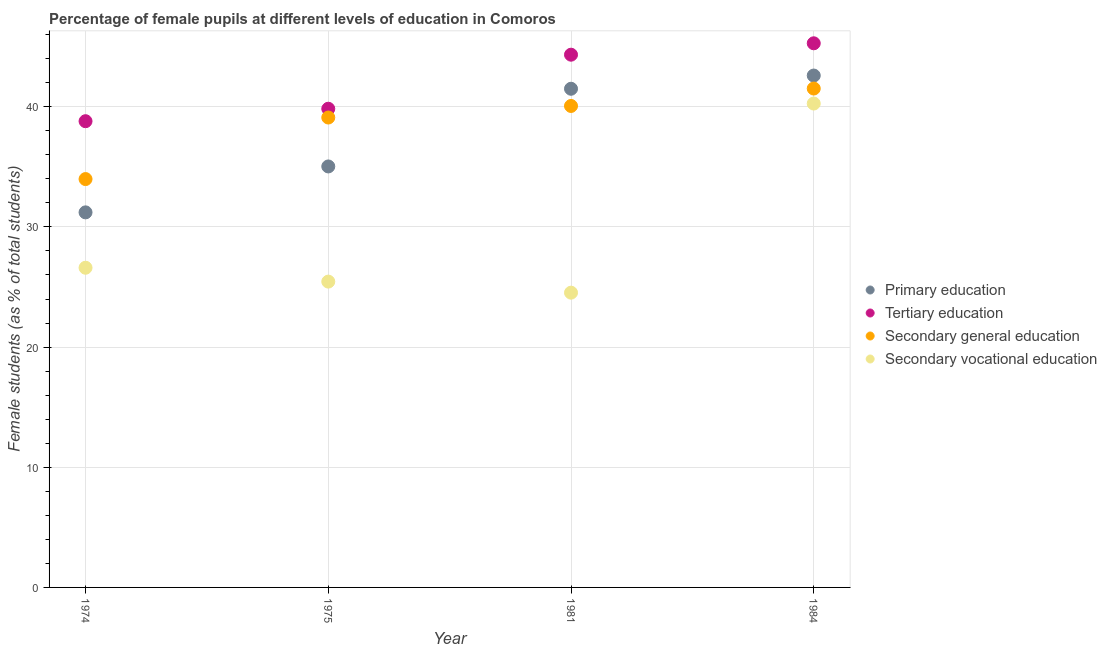What is the percentage of female students in secondary vocational education in 1981?
Your response must be concise. 24.53. Across all years, what is the maximum percentage of female students in secondary education?
Your response must be concise. 41.51. Across all years, what is the minimum percentage of female students in secondary vocational education?
Your answer should be compact. 24.53. In which year was the percentage of female students in tertiary education maximum?
Provide a succinct answer. 1984. In which year was the percentage of female students in secondary vocational education minimum?
Keep it short and to the point. 1981. What is the total percentage of female students in primary education in the graph?
Keep it short and to the point. 150.33. What is the difference between the percentage of female students in secondary education in 1974 and that in 1975?
Ensure brevity in your answer.  -5.12. What is the difference between the percentage of female students in secondary education in 1981 and the percentage of female students in secondary vocational education in 1974?
Provide a succinct answer. 13.46. What is the average percentage of female students in secondary vocational education per year?
Provide a short and direct response. 29.21. In the year 1975, what is the difference between the percentage of female students in primary education and percentage of female students in secondary vocational education?
Provide a short and direct response. 9.58. What is the ratio of the percentage of female students in secondary vocational education in 1975 to that in 1981?
Your response must be concise. 1.04. Is the percentage of female students in secondary vocational education in 1981 less than that in 1984?
Offer a terse response. Yes. Is the difference between the percentage of female students in tertiary education in 1981 and 1984 greater than the difference between the percentage of female students in primary education in 1981 and 1984?
Keep it short and to the point. Yes. What is the difference between the highest and the second highest percentage of female students in tertiary education?
Offer a very short reply. 0.95. What is the difference between the highest and the lowest percentage of female students in tertiary education?
Your response must be concise. 6.48. In how many years, is the percentage of female students in primary education greater than the average percentage of female students in primary education taken over all years?
Provide a succinct answer. 2. Does the percentage of female students in primary education monotonically increase over the years?
Provide a short and direct response. Yes. Is the percentage of female students in primary education strictly greater than the percentage of female students in secondary vocational education over the years?
Provide a succinct answer. Yes. What is the difference between two consecutive major ticks on the Y-axis?
Your answer should be compact. 10. Does the graph contain grids?
Offer a terse response. Yes. How are the legend labels stacked?
Offer a terse response. Vertical. What is the title of the graph?
Offer a very short reply. Percentage of female pupils at different levels of education in Comoros. What is the label or title of the Y-axis?
Provide a succinct answer. Female students (as % of total students). What is the Female students (as % of total students) in Primary education in 1974?
Your response must be concise. 31.21. What is the Female students (as % of total students) in Tertiary education in 1974?
Your answer should be compact. 38.8. What is the Female students (as % of total students) of Secondary general education in 1974?
Keep it short and to the point. 33.98. What is the Female students (as % of total students) in Secondary vocational education in 1974?
Keep it short and to the point. 26.6. What is the Female students (as % of total students) in Primary education in 1975?
Give a very brief answer. 35.03. What is the Female students (as % of total students) of Tertiary education in 1975?
Make the answer very short. 39.83. What is the Female students (as % of total students) of Secondary general education in 1975?
Your answer should be compact. 39.1. What is the Female students (as % of total students) in Secondary vocational education in 1975?
Your response must be concise. 25.45. What is the Female students (as % of total students) of Primary education in 1981?
Your response must be concise. 41.5. What is the Female students (as % of total students) in Tertiary education in 1981?
Your answer should be compact. 44.33. What is the Female students (as % of total students) in Secondary general education in 1981?
Ensure brevity in your answer.  40.06. What is the Female students (as % of total students) of Secondary vocational education in 1981?
Your answer should be compact. 24.53. What is the Female students (as % of total students) in Primary education in 1984?
Your answer should be compact. 42.6. What is the Female students (as % of total students) in Tertiary education in 1984?
Your answer should be very brief. 45.28. What is the Female students (as % of total students) in Secondary general education in 1984?
Keep it short and to the point. 41.51. What is the Female students (as % of total students) in Secondary vocational education in 1984?
Your answer should be compact. 40.27. Across all years, what is the maximum Female students (as % of total students) of Primary education?
Provide a succinct answer. 42.6. Across all years, what is the maximum Female students (as % of total students) of Tertiary education?
Your answer should be very brief. 45.28. Across all years, what is the maximum Female students (as % of total students) in Secondary general education?
Keep it short and to the point. 41.51. Across all years, what is the maximum Female students (as % of total students) of Secondary vocational education?
Offer a very short reply. 40.27. Across all years, what is the minimum Female students (as % of total students) of Primary education?
Provide a short and direct response. 31.21. Across all years, what is the minimum Female students (as % of total students) in Tertiary education?
Your answer should be compact. 38.8. Across all years, what is the minimum Female students (as % of total students) of Secondary general education?
Your response must be concise. 33.98. Across all years, what is the minimum Female students (as % of total students) in Secondary vocational education?
Give a very brief answer. 24.53. What is the total Female students (as % of total students) of Primary education in the graph?
Make the answer very short. 150.33. What is the total Female students (as % of total students) in Tertiary education in the graph?
Ensure brevity in your answer.  168.24. What is the total Female students (as % of total students) in Secondary general education in the graph?
Provide a succinct answer. 154.66. What is the total Female students (as % of total students) in Secondary vocational education in the graph?
Your response must be concise. 116.84. What is the difference between the Female students (as % of total students) of Primary education in 1974 and that in 1975?
Your answer should be compact. -3.82. What is the difference between the Female students (as % of total students) of Tertiary education in 1974 and that in 1975?
Offer a terse response. -1.04. What is the difference between the Female students (as % of total students) in Secondary general education in 1974 and that in 1975?
Your answer should be very brief. -5.12. What is the difference between the Female students (as % of total students) in Secondary vocational education in 1974 and that in 1975?
Offer a very short reply. 1.15. What is the difference between the Female students (as % of total students) in Primary education in 1974 and that in 1981?
Your answer should be very brief. -10.29. What is the difference between the Female students (as % of total students) in Tertiary education in 1974 and that in 1981?
Keep it short and to the point. -5.53. What is the difference between the Female students (as % of total students) of Secondary general education in 1974 and that in 1981?
Offer a very short reply. -6.08. What is the difference between the Female students (as % of total students) in Secondary vocational education in 1974 and that in 1981?
Your answer should be very brief. 2.07. What is the difference between the Female students (as % of total students) in Primary education in 1974 and that in 1984?
Give a very brief answer. -11.39. What is the difference between the Female students (as % of total students) in Tertiary education in 1974 and that in 1984?
Provide a short and direct response. -6.48. What is the difference between the Female students (as % of total students) of Secondary general education in 1974 and that in 1984?
Ensure brevity in your answer.  -7.53. What is the difference between the Female students (as % of total students) of Secondary vocational education in 1974 and that in 1984?
Provide a succinct answer. -13.66. What is the difference between the Female students (as % of total students) of Primary education in 1975 and that in 1981?
Keep it short and to the point. -6.46. What is the difference between the Female students (as % of total students) of Tertiary education in 1975 and that in 1981?
Provide a succinct answer. -4.5. What is the difference between the Female students (as % of total students) in Secondary general education in 1975 and that in 1981?
Your answer should be very brief. -0.96. What is the difference between the Female students (as % of total students) in Secondary vocational education in 1975 and that in 1981?
Your answer should be compact. 0.92. What is the difference between the Female students (as % of total students) of Primary education in 1975 and that in 1984?
Ensure brevity in your answer.  -7.56. What is the difference between the Female students (as % of total students) in Tertiary education in 1975 and that in 1984?
Your response must be concise. -5.45. What is the difference between the Female students (as % of total students) of Secondary general education in 1975 and that in 1984?
Make the answer very short. -2.41. What is the difference between the Female students (as % of total students) of Secondary vocational education in 1975 and that in 1984?
Offer a very short reply. -14.82. What is the difference between the Female students (as % of total students) in Primary education in 1981 and that in 1984?
Provide a succinct answer. -1.1. What is the difference between the Female students (as % of total students) in Tertiary education in 1981 and that in 1984?
Offer a very short reply. -0.95. What is the difference between the Female students (as % of total students) in Secondary general education in 1981 and that in 1984?
Your answer should be very brief. -1.45. What is the difference between the Female students (as % of total students) in Secondary vocational education in 1981 and that in 1984?
Give a very brief answer. -15.74. What is the difference between the Female students (as % of total students) of Primary education in 1974 and the Female students (as % of total students) of Tertiary education in 1975?
Your answer should be very brief. -8.62. What is the difference between the Female students (as % of total students) of Primary education in 1974 and the Female students (as % of total students) of Secondary general education in 1975?
Offer a terse response. -7.89. What is the difference between the Female students (as % of total students) of Primary education in 1974 and the Female students (as % of total students) of Secondary vocational education in 1975?
Your answer should be very brief. 5.76. What is the difference between the Female students (as % of total students) in Tertiary education in 1974 and the Female students (as % of total students) in Secondary general education in 1975?
Your answer should be very brief. -0.31. What is the difference between the Female students (as % of total students) of Tertiary education in 1974 and the Female students (as % of total students) of Secondary vocational education in 1975?
Your response must be concise. 13.35. What is the difference between the Female students (as % of total students) in Secondary general education in 1974 and the Female students (as % of total students) in Secondary vocational education in 1975?
Offer a very short reply. 8.53. What is the difference between the Female students (as % of total students) of Primary education in 1974 and the Female students (as % of total students) of Tertiary education in 1981?
Keep it short and to the point. -13.12. What is the difference between the Female students (as % of total students) in Primary education in 1974 and the Female students (as % of total students) in Secondary general education in 1981?
Provide a short and direct response. -8.85. What is the difference between the Female students (as % of total students) of Primary education in 1974 and the Female students (as % of total students) of Secondary vocational education in 1981?
Provide a short and direct response. 6.68. What is the difference between the Female students (as % of total students) of Tertiary education in 1974 and the Female students (as % of total students) of Secondary general education in 1981?
Offer a terse response. -1.27. What is the difference between the Female students (as % of total students) in Tertiary education in 1974 and the Female students (as % of total students) in Secondary vocational education in 1981?
Your answer should be compact. 14.27. What is the difference between the Female students (as % of total students) of Secondary general education in 1974 and the Female students (as % of total students) of Secondary vocational education in 1981?
Provide a short and direct response. 9.45. What is the difference between the Female students (as % of total students) of Primary education in 1974 and the Female students (as % of total students) of Tertiary education in 1984?
Give a very brief answer. -14.07. What is the difference between the Female students (as % of total students) of Primary education in 1974 and the Female students (as % of total students) of Secondary general education in 1984?
Give a very brief answer. -10.3. What is the difference between the Female students (as % of total students) in Primary education in 1974 and the Female students (as % of total students) in Secondary vocational education in 1984?
Offer a very short reply. -9.05. What is the difference between the Female students (as % of total students) of Tertiary education in 1974 and the Female students (as % of total students) of Secondary general education in 1984?
Offer a terse response. -2.72. What is the difference between the Female students (as % of total students) in Tertiary education in 1974 and the Female students (as % of total students) in Secondary vocational education in 1984?
Ensure brevity in your answer.  -1.47. What is the difference between the Female students (as % of total students) in Secondary general education in 1974 and the Female students (as % of total students) in Secondary vocational education in 1984?
Offer a very short reply. -6.28. What is the difference between the Female students (as % of total students) of Primary education in 1975 and the Female students (as % of total students) of Tertiary education in 1981?
Offer a very short reply. -9.3. What is the difference between the Female students (as % of total students) in Primary education in 1975 and the Female students (as % of total students) in Secondary general education in 1981?
Provide a succinct answer. -5.03. What is the difference between the Female students (as % of total students) in Primary education in 1975 and the Female students (as % of total students) in Secondary vocational education in 1981?
Offer a very short reply. 10.5. What is the difference between the Female students (as % of total students) in Tertiary education in 1975 and the Female students (as % of total students) in Secondary general education in 1981?
Make the answer very short. -0.23. What is the difference between the Female students (as % of total students) of Tertiary education in 1975 and the Female students (as % of total students) of Secondary vocational education in 1981?
Give a very brief answer. 15.31. What is the difference between the Female students (as % of total students) in Secondary general education in 1975 and the Female students (as % of total students) in Secondary vocational education in 1981?
Offer a very short reply. 14.57. What is the difference between the Female students (as % of total students) in Primary education in 1975 and the Female students (as % of total students) in Tertiary education in 1984?
Provide a short and direct response. -10.25. What is the difference between the Female students (as % of total students) of Primary education in 1975 and the Female students (as % of total students) of Secondary general education in 1984?
Your answer should be very brief. -6.48. What is the difference between the Female students (as % of total students) in Primary education in 1975 and the Female students (as % of total students) in Secondary vocational education in 1984?
Provide a short and direct response. -5.23. What is the difference between the Female students (as % of total students) of Tertiary education in 1975 and the Female students (as % of total students) of Secondary general education in 1984?
Offer a very short reply. -1.68. What is the difference between the Female students (as % of total students) in Tertiary education in 1975 and the Female students (as % of total students) in Secondary vocational education in 1984?
Keep it short and to the point. -0.43. What is the difference between the Female students (as % of total students) of Secondary general education in 1975 and the Female students (as % of total students) of Secondary vocational education in 1984?
Your answer should be very brief. -1.16. What is the difference between the Female students (as % of total students) in Primary education in 1981 and the Female students (as % of total students) in Tertiary education in 1984?
Your answer should be compact. -3.78. What is the difference between the Female students (as % of total students) of Primary education in 1981 and the Female students (as % of total students) of Secondary general education in 1984?
Give a very brief answer. -0.02. What is the difference between the Female students (as % of total students) of Primary education in 1981 and the Female students (as % of total students) of Secondary vocational education in 1984?
Ensure brevity in your answer.  1.23. What is the difference between the Female students (as % of total students) in Tertiary education in 1981 and the Female students (as % of total students) in Secondary general education in 1984?
Provide a short and direct response. 2.82. What is the difference between the Female students (as % of total students) of Tertiary education in 1981 and the Female students (as % of total students) of Secondary vocational education in 1984?
Offer a terse response. 4.07. What is the difference between the Female students (as % of total students) of Secondary general education in 1981 and the Female students (as % of total students) of Secondary vocational education in 1984?
Offer a very short reply. -0.2. What is the average Female students (as % of total students) of Primary education per year?
Your answer should be compact. 37.58. What is the average Female students (as % of total students) of Tertiary education per year?
Give a very brief answer. 42.06. What is the average Female students (as % of total students) in Secondary general education per year?
Provide a short and direct response. 38.67. What is the average Female students (as % of total students) of Secondary vocational education per year?
Offer a terse response. 29.21. In the year 1974, what is the difference between the Female students (as % of total students) in Primary education and Female students (as % of total students) in Tertiary education?
Provide a succinct answer. -7.59. In the year 1974, what is the difference between the Female students (as % of total students) in Primary education and Female students (as % of total students) in Secondary general education?
Provide a succinct answer. -2.77. In the year 1974, what is the difference between the Female students (as % of total students) of Primary education and Female students (as % of total students) of Secondary vocational education?
Your response must be concise. 4.61. In the year 1974, what is the difference between the Female students (as % of total students) in Tertiary education and Female students (as % of total students) in Secondary general education?
Ensure brevity in your answer.  4.82. In the year 1974, what is the difference between the Female students (as % of total students) in Tertiary education and Female students (as % of total students) in Secondary vocational education?
Your response must be concise. 12.19. In the year 1974, what is the difference between the Female students (as % of total students) in Secondary general education and Female students (as % of total students) in Secondary vocational education?
Ensure brevity in your answer.  7.38. In the year 1975, what is the difference between the Female students (as % of total students) in Primary education and Female students (as % of total students) in Tertiary education?
Provide a succinct answer. -4.8. In the year 1975, what is the difference between the Female students (as % of total students) in Primary education and Female students (as % of total students) in Secondary general education?
Your answer should be very brief. -4.07. In the year 1975, what is the difference between the Female students (as % of total students) of Primary education and Female students (as % of total students) of Secondary vocational education?
Keep it short and to the point. 9.58. In the year 1975, what is the difference between the Female students (as % of total students) in Tertiary education and Female students (as % of total students) in Secondary general education?
Your answer should be very brief. 0.73. In the year 1975, what is the difference between the Female students (as % of total students) in Tertiary education and Female students (as % of total students) in Secondary vocational education?
Your answer should be very brief. 14.38. In the year 1975, what is the difference between the Female students (as % of total students) in Secondary general education and Female students (as % of total students) in Secondary vocational education?
Offer a terse response. 13.65. In the year 1981, what is the difference between the Female students (as % of total students) of Primary education and Female students (as % of total students) of Tertiary education?
Make the answer very short. -2.83. In the year 1981, what is the difference between the Female students (as % of total students) of Primary education and Female students (as % of total students) of Secondary general education?
Your answer should be very brief. 1.43. In the year 1981, what is the difference between the Female students (as % of total students) of Primary education and Female students (as % of total students) of Secondary vocational education?
Your response must be concise. 16.97. In the year 1981, what is the difference between the Female students (as % of total students) of Tertiary education and Female students (as % of total students) of Secondary general education?
Ensure brevity in your answer.  4.27. In the year 1981, what is the difference between the Female students (as % of total students) of Tertiary education and Female students (as % of total students) of Secondary vocational education?
Offer a very short reply. 19.8. In the year 1981, what is the difference between the Female students (as % of total students) of Secondary general education and Female students (as % of total students) of Secondary vocational education?
Your response must be concise. 15.54. In the year 1984, what is the difference between the Female students (as % of total students) of Primary education and Female students (as % of total students) of Tertiary education?
Offer a very short reply. -2.68. In the year 1984, what is the difference between the Female students (as % of total students) of Primary education and Female students (as % of total students) of Secondary general education?
Make the answer very short. 1.08. In the year 1984, what is the difference between the Female students (as % of total students) in Primary education and Female students (as % of total students) in Secondary vocational education?
Give a very brief answer. 2.33. In the year 1984, what is the difference between the Female students (as % of total students) of Tertiary education and Female students (as % of total students) of Secondary general education?
Keep it short and to the point. 3.76. In the year 1984, what is the difference between the Female students (as % of total students) in Tertiary education and Female students (as % of total students) in Secondary vocational education?
Give a very brief answer. 5.01. In the year 1984, what is the difference between the Female students (as % of total students) in Secondary general education and Female students (as % of total students) in Secondary vocational education?
Give a very brief answer. 1.25. What is the ratio of the Female students (as % of total students) of Primary education in 1974 to that in 1975?
Your response must be concise. 0.89. What is the ratio of the Female students (as % of total students) of Tertiary education in 1974 to that in 1975?
Your answer should be very brief. 0.97. What is the ratio of the Female students (as % of total students) in Secondary general education in 1974 to that in 1975?
Your response must be concise. 0.87. What is the ratio of the Female students (as % of total students) in Secondary vocational education in 1974 to that in 1975?
Ensure brevity in your answer.  1.05. What is the ratio of the Female students (as % of total students) of Primary education in 1974 to that in 1981?
Keep it short and to the point. 0.75. What is the ratio of the Female students (as % of total students) in Tertiary education in 1974 to that in 1981?
Provide a short and direct response. 0.88. What is the ratio of the Female students (as % of total students) in Secondary general education in 1974 to that in 1981?
Your response must be concise. 0.85. What is the ratio of the Female students (as % of total students) of Secondary vocational education in 1974 to that in 1981?
Your response must be concise. 1.08. What is the ratio of the Female students (as % of total students) of Primary education in 1974 to that in 1984?
Your answer should be compact. 0.73. What is the ratio of the Female students (as % of total students) in Tertiary education in 1974 to that in 1984?
Give a very brief answer. 0.86. What is the ratio of the Female students (as % of total students) of Secondary general education in 1974 to that in 1984?
Give a very brief answer. 0.82. What is the ratio of the Female students (as % of total students) in Secondary vocational education in 1974 to that in 1984?
Ensure brevity in your answer.  0.66. What is the ratio of the Female students (as % of total students) of Primary education in 1975 to that in 1981?
Ensure brevity in your answer.  0.84. What is the ratio of the Female students (as % of total students) of Tertiary education in 1975 to that in 1981?
Provide a short and direct response. 0.9. What is the ratio of the Female students (as % of total students) of Secondary general education in 1975 to that in 1981?
Offer a very short reply. 0.98. What is the ratio of the Female students (as % of total students) of Secondary vocational education in 1975 to that in 1981?
Provide a succinct answer. 1.04. What is the ratio of the Female students (as % of total students) of Primary education in 1975 to that in 1984?
Give a very brief answer. 0.82. What is the ratio of the Female students (as % of total students) of Tertiary education in 1975 to that in 1984?
Your answer should be compact. 0.88. What is the ratio of the Female students (as % of total students) of Secondary general education in 1975 to that in 1984?
Your answer should be compact. 0.94. What is the ratio of the Female students (as % of total students) of Secondary vocational education in 1975 to that in 1984?
Offer a terse response. 0.63. What is the ratio of the Female students (as % of total students) of Primary education in 1981 to that in 1984?
Provide a short and direct response. 0.97. What is the ratio of the Female students (as % of total students) in Tertiary education in 1981 to that in 1984?
Ensure brevity in your answer.  0.98. What is the ratio of the Female students (as % of total students) of Secondary general education in 1981 to that in 1984?
Your response must be concise. 0.97. What is the ratio of the Female students (as % of total students) of Secondary vocational education in 1981 to that in 1984?
Offer a terse response. 0.61. What is the difference between the highest and the second highest Female students (as % of total students) of Primary education?
Provide a succinct answer. 1.1. What is the difference between the highest and the second highest Female students (as % of total students) of Tertiary education?
Keep it short and to the point. 0.95. What is the difference between the highest and the second highest Female students (as % of total students) of Secondary general education?
Offer a terse response. 1.45. What is the difference between the highest and the second highest Female students (as % of total students) of Secondary vocational education?
Ensure brevity in your answer.  13.66. What is the difference between the highest and the lowest Female students (as % of total students) of Primary education?
Provide a short and direct response. 11.39. What is the difference between the highest and the lowest Female students (as % of total students) of Tertiary education?
Ensure brevity in your answer.  6.48. What is the difference between the highest and the lowest Female students (as % of total students) in Secondary general education?
Provide a short and direct response. 7.53. What is the difference between the highest and the lowest Female students (as % of total students) of Secondary vocational education?
Give a very brief answer. 15.74. 